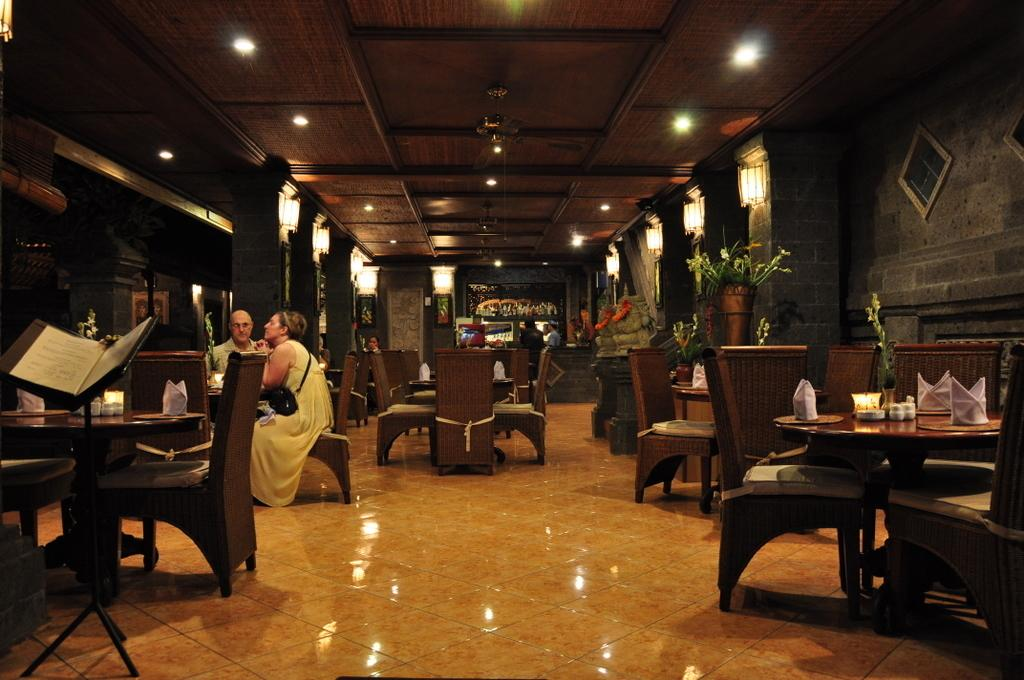How many people are present in the image? There are two people, a man and a woman, present in the image. What are the man and woman doing in the image? Both the man and woman are sitting on chairs in the image. What other objects can be seen in the image? There are tables, pillars, and lights visible in the image. Are there any other people visible in the image? Yes, there are people visible in the background of the image. What type of alarm is ringing in the image? There is no alarm present in the image. What letters are being exchanged between the man and woman in the image? There are no letters being exchanged between the man and woman in the image; they are simply sitting on chairs. 